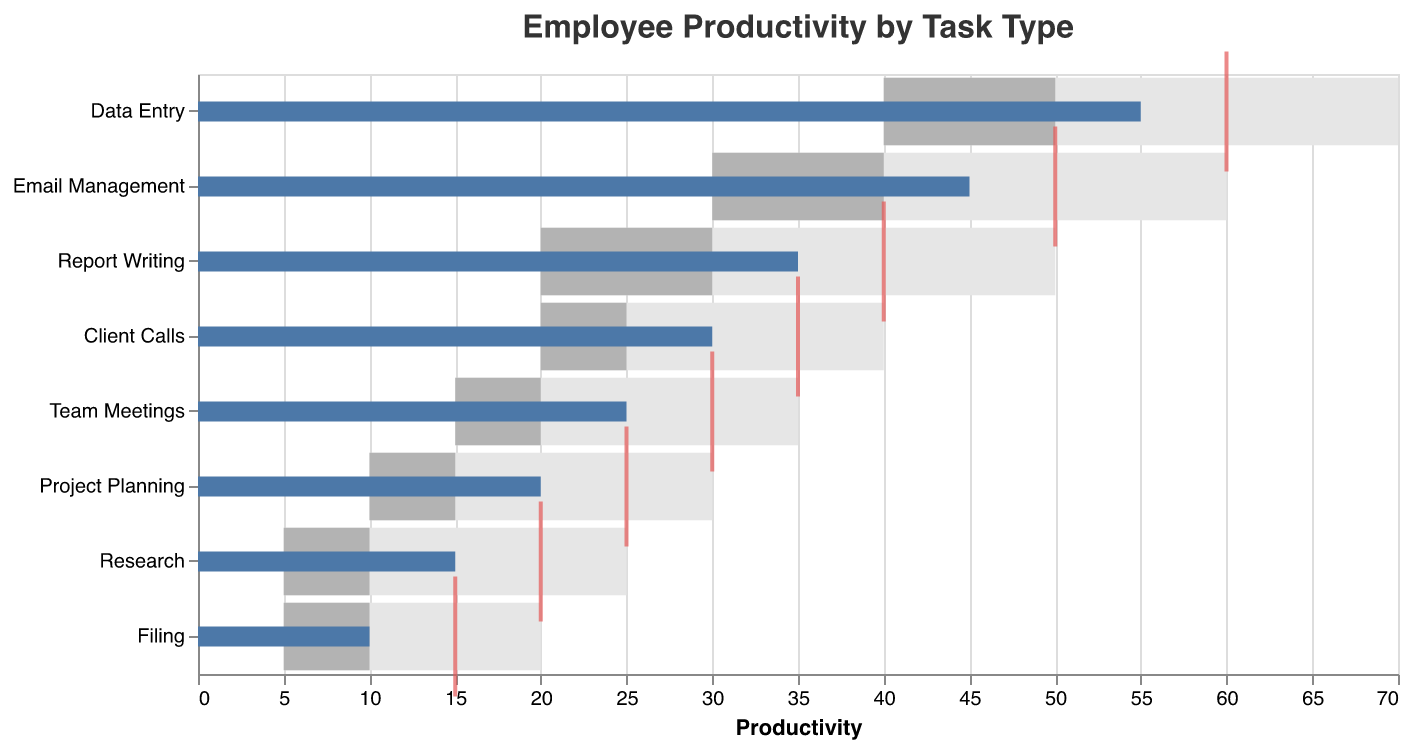What's the title of the figure? The title is usually prominently displayed at the top of the figure.
Answer: Employee Productivity by Task Type How many task types are displayed in the figure? Count each unique task type listed on the y-axis of the figure.
Answer: 8 Which task type has the highest actual productivity? Identify the bar representing actual productivity that extends the farthest to the right.
Answer: Data Entry Is the actual productivity for "Email Management" above or below its target? Compare the location of the actual productivity bar for "Email Management" with the tick mark representing the target.
Answer: Below Which task type has the smallest gap between actual and target productivity? Determine the task with the smallest visual distance between the actual productivity bar and the target tick mark.
Answer: Client Calls What's the range of values considered "Satisfactory" for "Team Meetings"? Look at the left and right bounds of the lighter grey bar for "Team Meetings".
Answer: 15 to 20 Calculate the difference between target and actual productivity for "Data Entry". Subtract actual productivity from the target productivity for "Data Entry": 60 - 55 = 5.
Answer: 5 Which task type is closest to achieving its "Good" productivity threshold? Compare the end of the actual productivity bar to the "Good" threshold for each task type.
Answer: Data Entry What's the total combined actual productivity for "Project Planning" and "Research"? Sum the actual productivity values for these two task types: 20 + 15 = 35.
Answer: 35 Which task has the lowest actual productivity and what is that value? Identify the task type with the shortest actual productivity bar and note its value.
Answer: Filing, 10 